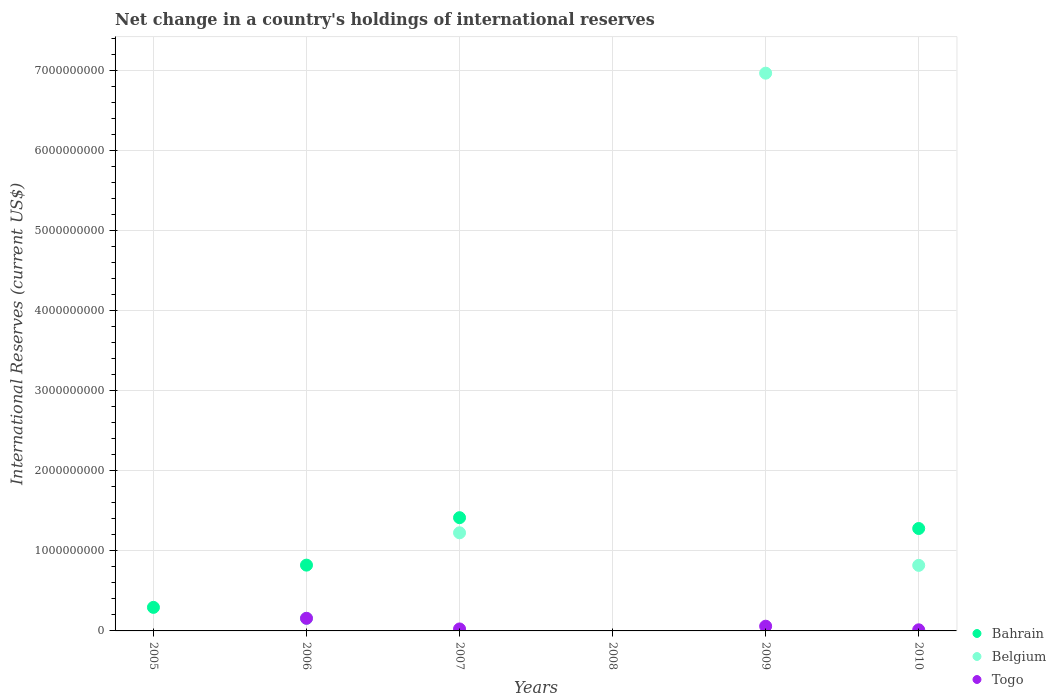Is the number of dotlines equal to the number of legend labels?
Provide a succinct answer. No. What is the international reserves in Togo in 2007?
Provide a succinct answer. 2.47e+07. Across all years, what is the maximum international reserves in Belgium?
Your response must be concise. 6.97e+09. Across all years, what is the minimum international reserves in Belgium?
Give a very brief answer. 0. What is the total international reserves in Belgium in the graph?
Make the answer very short. 9.17e+09. What is the difference between the international reserves in Bahrain in 2006 and that in 2010?
Provide a short and direct response. -4.58e+08. What is the difference between the international reserves in Bahrain in 2005 and the international reserves in Belgium in 2008?
Ensure brevity in your answer.  2.94e+08. What is the average international reserves in Bahrain per year?
Give a very brief answer. 6.35e+08. In the year 2007, what is the difference between the international reserves in Belgium and international reserves in Bahrain?
Make the answer very short. -1.89e+08. In how many years, is the international reserves in Belgium greater than 3800000000 US$?
Keep it short and to the point. 1. What is the ratio of the international reserves in Belgium in 2009 to that in 2010?
Your answer should be compact. 8.51. Is the international reserves in Togo in 2006 less than that in 2010?
Provide a succinct answer. No. Is the difference between the international reserves in Belgium in 2006 and 2007 greater than the difference between the international reserves in Bahrain in 2006 and 2007?
Give a very brief answer. No. What is the difference between the highest and the second highest international reserves in Togo?
Provide a succinct answer. 9.88e+07. What is the difference between the highest and the lowest international reserves in Bahrain?
Ensure brevity in your answer.  1.41e+09. Is it the case that in every year, the sum of the international reserves in Togo and international reserves in Bahrain  is greater than the international reserves in Belgium?
Make the answer very short. No. Does the international reserves in Bahrain monotonically increase over the years?
Your response must be concise. No. Is the international reserves in Belgium strictly greater than the international reserves in Togo over the years?
Your answer should be compact. No. Is the international reserves in Belgium strictly less than the international reserves in Togo over the years?
Keep it short and to the point. No. How many years are there in the graph?
Your response must be concise. 6. What is the difference between two consecutive major ticks on the Y-axis?
Make the answer very short. 1.00e+09. Are the values on the major ticks of Y-axis written in scientific E-notation?
Your answer should be compact. No. Does the graph contain any zero values?
Your answer should be very brief. Yes. How many legend labels are there?
Your response must be concise. 3. What is the title of the graph?
Your response must be concise. Net change in a country's holdings of international reserves. Does "Malta" appear as one of the legend labels in the graph?
Keep it short and to the point. No. What is the label or title of the Y-axis?
Ensure brevity in your answer.  International Reserves (current US$). What is the International Reserves (current US$) of Bahrain in 2005?
Make the answer very short. 2.94e+08. What is the International Reserves (current US$) of Belgium in 2005?
Provide a succinct answer. 0. What is the International Reserves (current US$) in Bahrain in 2006?
Your answer should be very brief. 8.22e+08. What is the International Reserves (current US$) of Belgium in 2006?
Offer a terse response. 1.56e+08. What is the International Reserves (current US$) of Togo in 2006?
Give a very brief answer. 1.58e+08. What is the International Reserves (current US$) in Bahrain in 2007?
Keep it short and to the point. 1.41e+09. What is the International Reserves (current US$) in Belgium in 2007?
Make the answer very short. 1.23e+09. What is the International Reserves (current US$) in Togo in 2007?
Keep it short and to the point. 2.47e+07. What is the International Reserves (current US$) of Bahrain in 2009?
Your answer should be very brief. 0. What is the International Reserves (current US$) of Belgium in 2009?
Provide a succinct answer. 6.97e+09. What is the International Reserves (current US$) in Togo in 2009?
Give a very brief answer. 5.90e+07. What is the International Reserves (current US$) in Bahrain in 2010?
Your answer should be compact. 1.28e+09. What is the International Reserves (current US$) in Belgium in 2010?
Give a very brief answer. 8.19e+08. What is the International Reserves (current US$) of Togo in 2010?
Your response must be concise. 1.39e+07. Across all years, what is the maximum International Reserves (current US$) in Bahrain?
Your answer should be compact. 1.41e+09. Across all years, what is the maximum International Reserves (current US$) in Belgium?
Keep it short and to the point. 6.97e+09. Across all years, what is the maximum International Reserves (current US$) of Togo?
Your response must be concise. 1.58e+08. Across all years, what is the minimum International Reserves (current US$) of Bahrain?
Your answer should be very brief. 0. Across all years, what is the minimum International Reserves (current US$) of Togo?
Give a very brief answer. 0. What is the total International Reserves (current US$) of Bahrain in the graph?
Offer a very short reply. 3.81e+09. What is the total International Reserves (current US$) in Belgium in the graph?
Ensure brevity in your answer.  9.17e+09. What is the total International Reserves (current US$) in Togo in the graph?
Offer a terse response. 2.55e+08. What is the difference between the International Reserves (current US$) in Bahrain in 2005 and that in 2006?
Offer a terse response. -5.28e+08. What is the difference between the International Reserves (current US$) of Bahrain in 2005 and that in 2007?
Offer a very short reply. -1.12e+09. What is the difference between the International Reserves (current US$) of Bahrain in 2005 and that in 2010?
Offer a very short reply. -9.85e+08. What is the difference between the International Reserves (current US$) in Bahrain in 2006 and that in 2007?
Offer a terse response. -5.93e+08. What is the difference between the International Reserves (current US$) of Belgium in 2006 and that in 2007?
Give a very brief answer. -1.07e+09. What is the difference between the International Reserves (current US$) in Togo in 2006 and that in 2007?
Provide a short and direct response. 1.33e+08. What is the difference between the International Reserves (current US$) in Belgium in 2006 and that in 2009?
Provide a succinct answer. -6.81e+09. What is the difference between the International Reserves (current US$) of Togo in 2006 and that in 2009?
Make the answer very short. 9.88e+07. What is the difference between the International Reserves (current US$) in Bahrain in 2006 and that in 2010?
Offer a terse response. -4.58e+08. What is the difference between the International Reserves (current US$) in Belgium in 2006 and that in 2010?
Keep it short and to the point. -6.63e+08. What is the difference between the International Reserves (current US$) of Togo in 2006 and that in 2010?
Offer a very short reply. 1.44e+08. What is the difference between the International Reserves (current US$) in Belgium in 2007 and that in 2009?
Offer a terse response. -5.74e+09. What is the difference between the International Reserves (current US$) of Togo in 2007 and that in 2009?
Provide a short and direct response. -3.43e+07. What is the difference between the International Reserves (current US$) of Bahrain in 2007 and that in 2010?
Provide a short and direct response. 1.35e+08. What is the difference between the International Reserves (current US$) of Belgium in 2007 and that in 2010?
Give a very brief answer. 4.07e+08. What is the difference between the International Reserves (current US$) of Togo in 2007 and that in 2010?
Offer a terse response. 1.08e+07. What is the difference between the International Reserves (current US$) in Belgium in 2009 and that in 2010?
Your answer should be very brief. 6.15e+09. What is the difference between the International Reserves (current US$) in Togo in 2009 and that in 2010?
Offer a terse response. 4.51e+07. What is the difference between the International Reserves (current US$) in Bahrain in 2005 and the International Reserves (current US$) in Belgium in 2006?
Your answer should be very brief. 1.38e+08. What is the difference between the International Reserves (current US$) in Bahrain in 2005 and the International Reserves (current US$) in Togo in 2006?
Give a very brief answer. 1.36e+08. What is the difference between the International Reserves (current US$) of Bahrain in 2005 and the International Reserves (current US$) of Belgium in 2007?
Give a very brief answer. -9.32e+08. What is the difference between the International Reserves (current US$) of Bahrain in 2005 and the International Reserves (current US$) of Togo in 2007?
Ensure brevity in your answer.  2.69e+08. What is the difference between the International Reserves (current US$) of Bahrain in 2005 and the International Reserves (current US$) of Belgium in 2009?
Provide a succinct answer. -6.67e+09. What is the difference between the International Reserves (current US$) in Bahrain in 2005 and the International Reserves (current US$) in Togo in 2009?
Your answer should be very brief. 2.35e+08. What is the difference between the International Reserves (current US$) of Bahrain in 2005 and the International Reserves (current US$) of Belgium in 2010?
Offer a terse response. -5.25e+08. What is the difference between the International Reserves (current US$) in Bahrain in 2005 and the International Reserves (current US$) in Togo in 2010?
Provide a short and direct response. 2.80e+08. What is the difference between the International Reserves (current US$) of Bahrain in 2006 and the International Reserves (current US$) of Belgium in 2007?
Make the answer very short. -4.04e+08. What is the difference between the International Reserves (current US$) of Bahrain in 2006 and the International Reserves (current US$) of Togo in 2007?
Make the answer very short. 7.97e+08. What is the difference between the International Reserves (current US$) in Belgium in 2006 and the International Reserves (current US$) in Togo in 2007?
Give a very brief answer. 1.31e+08. What is the difference between the International Reserves (current US$) of Bahrain in 2006 and the International Reserves (current US$) of Belgium in 2009?
Give a very brief answer. -6.15e+09. What is the difference between the International Reserves (current US$) of Bahrain in 2006 and the International Reserves (current US$) of Togo in 2009?
Keep it short and to the point. 7.63e+08. What is the difference between the International Reserves (current US$) in Belgium in 2006 and the International Reserves (current US$) in Togo in 2009?
Your answer should be very brief. 9.67e+07. What is the difference between the International Reserves (current US$) in Bahrain in 2006 and the International Reserves (current US$) in Belgium in 2010?
Ensure brevity in your answer.  2.90e+06. What is the difference between the International Reserves (current US$) of Bahrain in 2006 and the International Reserves (current US$) of Togo in 2010?
Offer a terse response. 8.08e+08. What is the difference between the International Reserves (current US$) in Belgium in 2006 and the International Reserves (current US$) in Togo in 2010?
Offer a very short reply. 1.42e+08. What is the difference between the International Reserves (current US$) of Bahrain in 2007 and the International Reserves (current US$) of Belgium in 2009?
Offer a very short reply. -5.55e+09. What is the difference between the International Reserves (current US$) in Bahrain in 2007 and the International Reserves (current US$) in Togo in 2009?
Offer a terse response. 1.36e+09. What is the difference between the International Reserves (current US$) in Belgium in 2007 and the International Reserves (current US$) in Togo in 2009?
Make the answer very short. 1.17e+09. What is the difference between the International Reserves (current US$) of Bahrain in 2007 and the International Reserves (current US$) of Belgium in 2010?
Your response must be concise. 5.96e+08. What is the difference between the International Reserves (current US$) of Bahrain in 2007 and the International Reserves (current US$) of Togo in 2010?
Your answer should be very brief. 1.40e+09. What is the difference between the International Reserves (current US$) in Belgium in 2007 and the International Reserves (current US$) in Togo in 2010?
Your answer should be compact. 1.21e+09. What is the difference between the International Reserves (current US$) in Belgium in 2009 and the International Reserves (current US$) in Togo in 2010?
Your answer should be very brief. 6.95e+09. What is the average International Reserves (current US$) in Bahrain per year?
Offer a terse response. 6.35e+08. What is the average International Reserves (current US$) of Belgium per year?
Make the answer very short. 1.53e+09. What is the average International Reserves (current US$) in Togo per year?
Offer a terse response. 4.26e+07. In the year 2006, what is the difference between the International Reserves (current US$) of Bahrain and International Reserves (current US$) of Belgium?
Provide a short and direct response. 6.66e+08. In the year 2006, what is the difference between the International Reserves (current US$) in Bahrain and International Reserves (current US$) in Togo?
Give a very brief answer. 6.64e+08. In the year 2006, what is the difference between the International Reserves (current US$) in Belgium and International Reserves (current US$) in Togo?
Provide a short and direct response. -2.13e+06. In the year 2007, what is the difference between the International Reserves (current US$) in Bahrain and International Reserves (current US$) in Belgium?
Your answer should be compact. 1.89e+08. In the year 2007, what is the difference between the International Reserves (current US$) of Bahrain and International Reserves (current US$) of Togo?
Your answer should be compact. 1.39e+09. In the year 2007, what is the difference between the International Reserves (current US$) of Belgium and International Reserves (current US$) of Togo?
Your answer should be compact. 1.20e+09. In the year 2009, what is the difference between the International Reserves (current US$) in Belgium and International Reserves (current US$) in Togo?
Make the answer very short. 6.91e+09. In the year 2010, what is the difference between the International Reserves (current US$) in Bahrain and International Reserves (current US$) in Belgium?
Offer a very short reply. 4.60e+08. In the year 2010, what is the difference between the International Reserves (current US$) in Bahrain and International Reserves (current US$) in Togo?
Provide a succinct answer. 1.27e+09. In the year 2010, what is the difference between the International Reserves (current US$) in Belgium and International Reserves (current US$) in Togo?
Provide a succinct answer. 8.05e+08. What is the ratio of the International Reserves (current US$) in Bahrain in 2005 to that in 2006?
Keep it short and to the point. 0.36. What is the ratio of the International Reserves (current US$) in Bahrain in 2005 to that in 2007?
Offer a very short reply. 0.21. What is the ratio of the International Reserves (current US$) in Bahrain in 2005 to that in 2010?
Your answer should be compact. 0.23. What is the ratio of the International Reserves (current US$) of Bahrain in 2006 to that in 2007?
Your answer should be very brief. 0.58. What is the ratio of the International Reserves (current US$) in Belgium in 2006 to that in 2007?
Offer a very short reply. 0.13. What is the ratio of the International Reserves (current US$) of Togo in 2006 to that in 2007?
Ensure brevity in your answer.  6.39. What is the ratio of the International Reserves (current US$) in Belgium in 2006 to that in 2009?
Ensure brevity in your answer.  0.02. What is the ratio of the International Reserves (current US$) of Togo in 2006 to that in 2009?
Ensure brevity in your answer.  2.67. What is the ratio of the International Reserves (current US$) of Bahrain in 2006 to that in 2010?
Offer a very short reply. 0.64. What is the ratio of the International Reserves (current US$) of Belgium in 2006 to that in 2010?
Provide a succinct answer. 0.19. What is the ratio of the International Reserves (current US$) of Togo in 2006 to that in 2010?
Provide a short and direct response. 11.36. What is the ratio of the International Reserves (current US$) in Belgium in 2007 to that in 2009?
Make the answer very short. 0.18. What is the ratio of the International Reserves (current US$) of Togo in 2007 to that in 2009?
Offer a terse response. 0.42. What is the ratio of the International Reserves (current US$) in Bahrain in 2007 to that in 2010?
Your answer should be very brief. 1.11. What is the ratio of the International Reserves (current US$) in Belgium in 2007 to that in 2010?
Your response must be concise. 1.5. What is the ratio of the International Reserves (current US$) in Togo in 2007 to that in 2010?
Make the answer very short. 1.78. What is the ratio of the International Reserves (current US$) of Belgium in 2009 to that in 2010?
Your response must be concise. 8.51. What is the ratio of the International Reserves (current US$) in Togo in 2009 to that in 2010?
Give a very brief answer. 4.25. What is the difference between the highest and the second highest International Reserves (current US$) of Bahrain?
Your answer should be very brief. 1.35e+08. What is the difference between the highest and the second highest International Reserves (current US$) of Belgium?
Provide a short and direct response. 5.74e+09. What is the difference between the highest and the second highest International Reserves (current US$) of Togo?
Offer a very short reply. 9.88e+07. What is the difference between the highest and the lowest International Reserves (current US$) in Bahrain?
Ensure brevity in your answer.  1.41e+09. What is the difference between the highest and the lowest International Reserves (current US$) in Belgium?
Offer a very short reply. 6.97e+09. What is the difference between the highest and the lowest International Reserves (current US$) in Togo?
Offer a very short reply. 1.58e+08. 